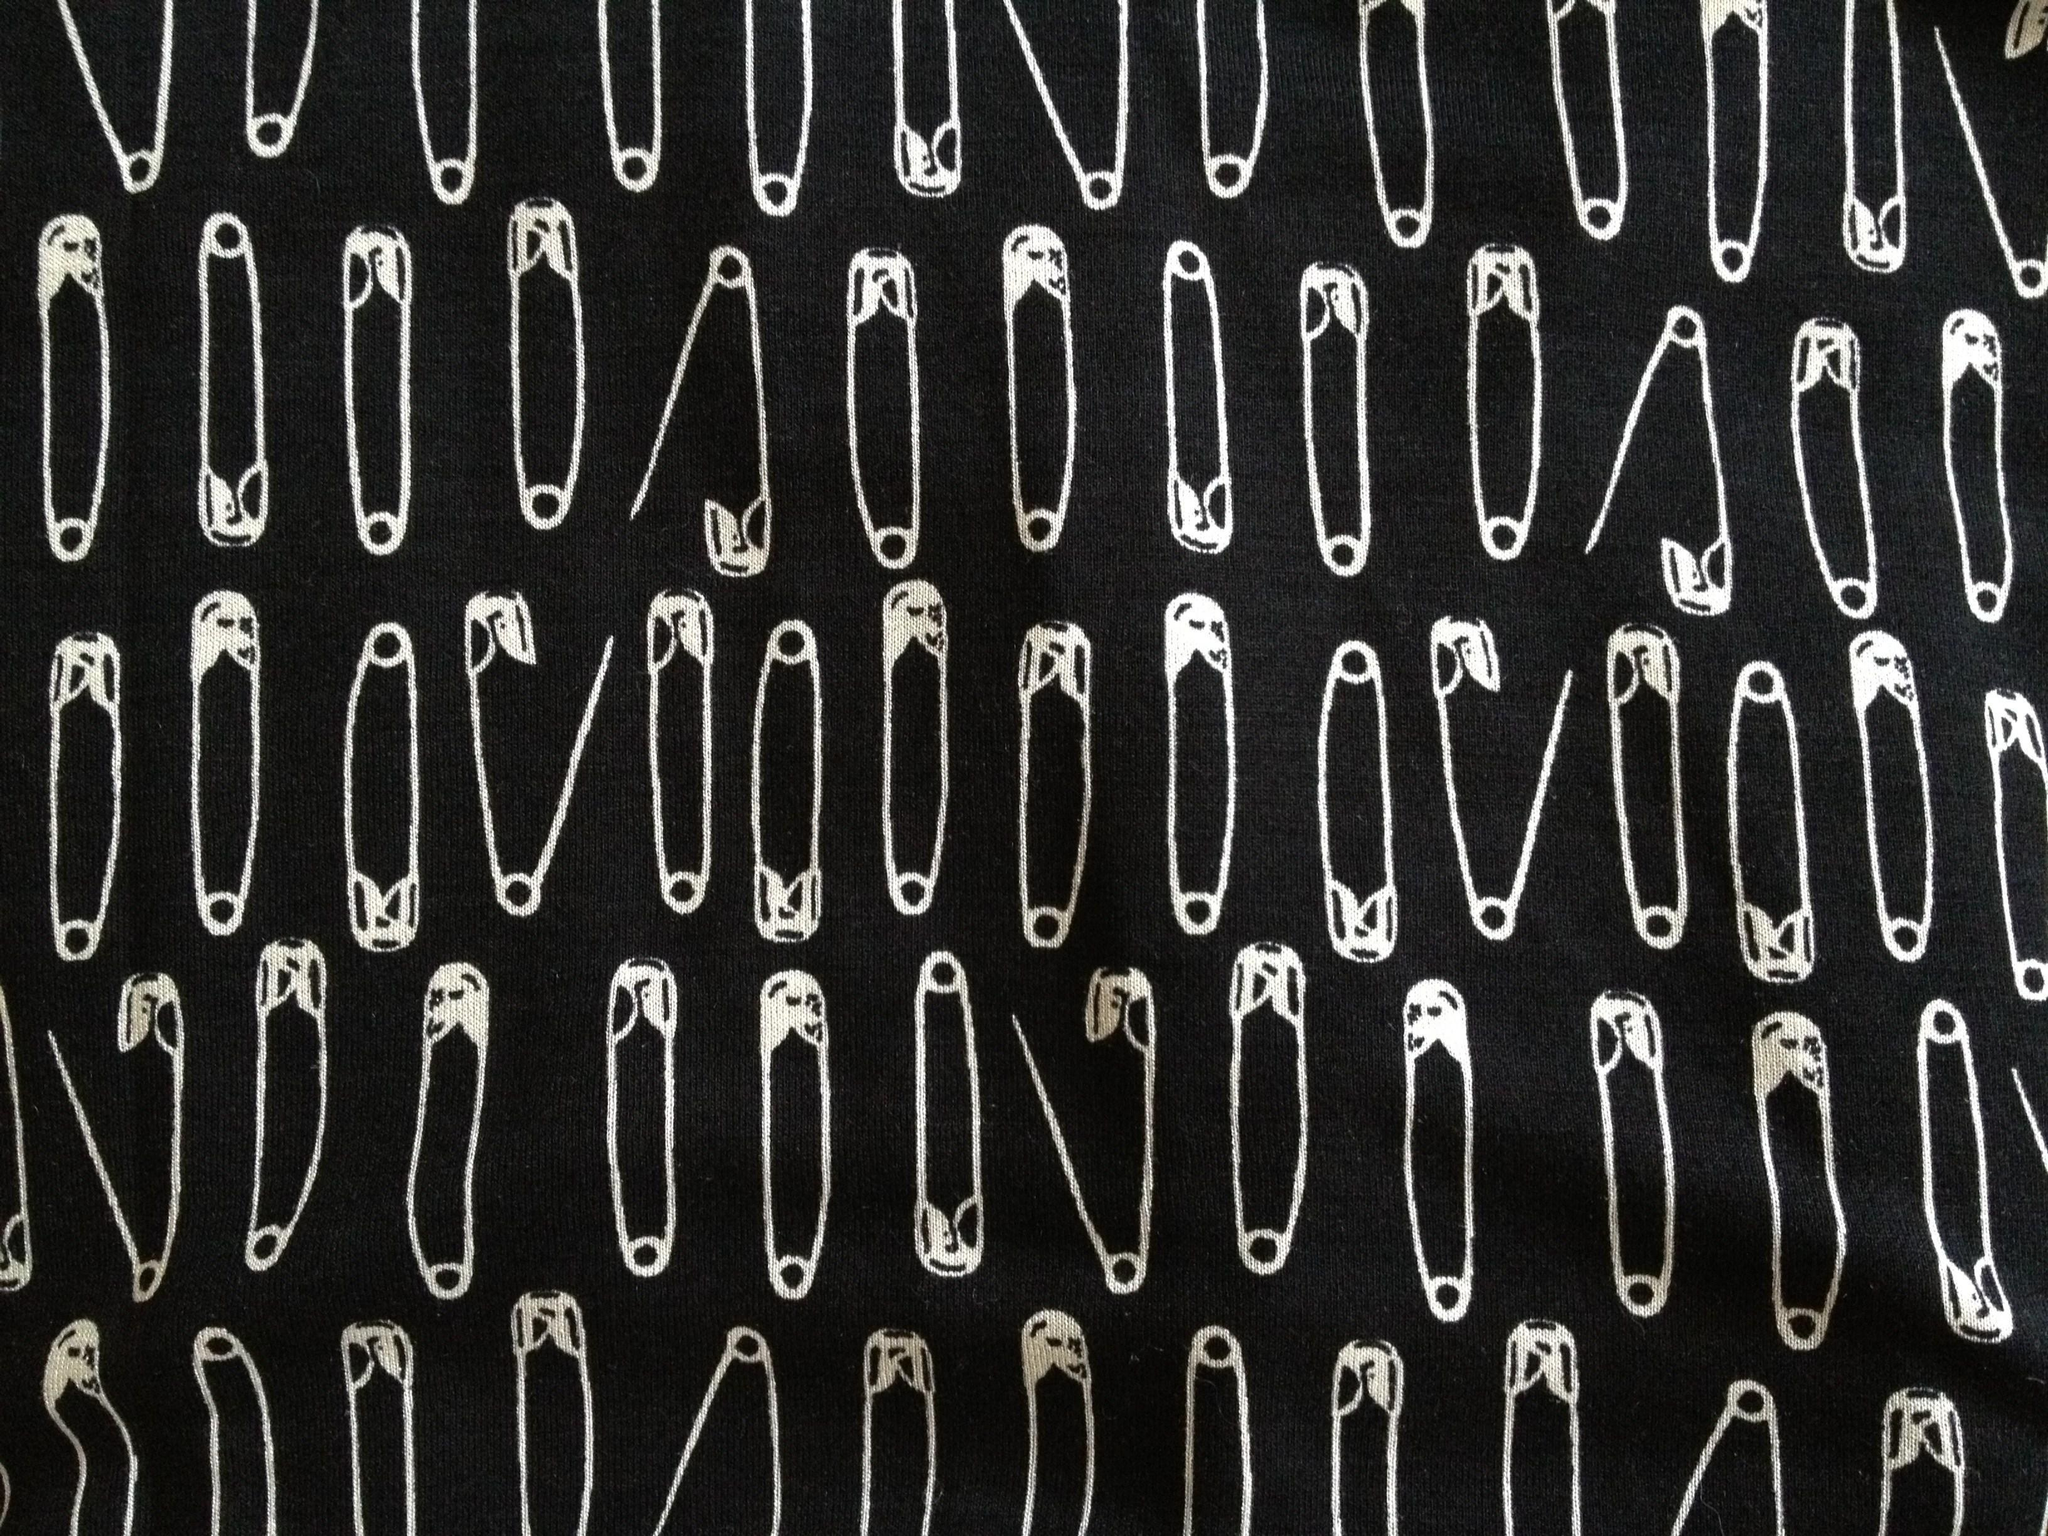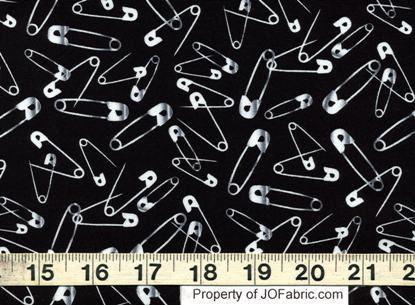The first image is the image on the left, the second image is the image on the right. Examine the images to the left and right. Is the description "At least one image in the pari has both gold and silver colored safety pins." accurate? Answer yes or no. No. 